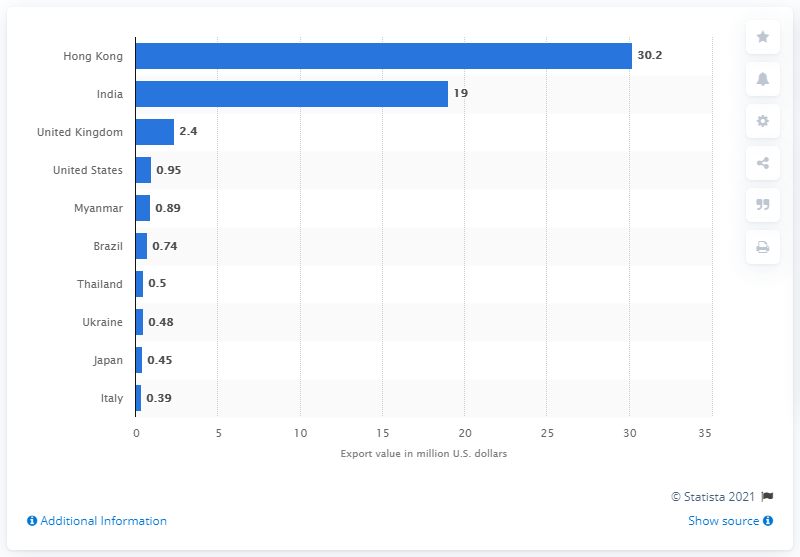Identify some key points in this picture. In 2019, the value of Hong Kong's human hair exports to the United States was approximately 30.2 million U.S. dollars. In 2019, India exported a significant amount of human hair valued at approximately $19 million. 